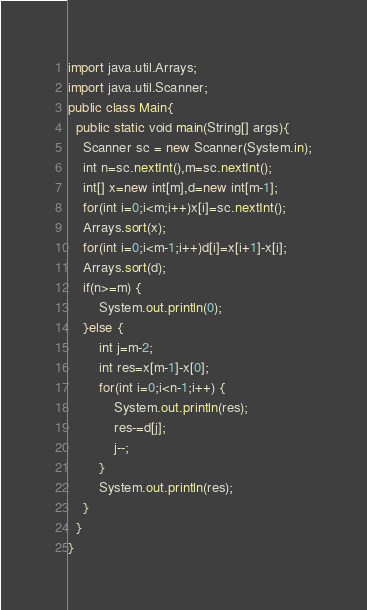<code> <loc_0><loc_0><loc_500><loc_500><_Java_>import java.util.Arrays;
import java.util.Scanner;
public class Main{
  public static void main(String[] args){
    Scanner sc = new Scanner(System.in);
    int n=sc.nextInt(),m=sc.nextInt();
    int[] x=new int[m],d=new int[m-1];
    for(int i=0;i<m;i++)x[i]=sc.nextInt();
    Arrays.sort(x);
    for(int i=0;i<m-1;i++)d[i]=x[i+1]-x[i];
    Arrays.sort(d);
    if(n>=m) {
    	System.out.println(0);
    }else {
    	int j=m-2;
    	int res=x[m-1]-x[0];
    	for(int i=0;i<n-1;i++) {
    		System.out.println(res);
    		res-=d[j];
    		j--;
    	}
    	System.out.println(res);
    }
  }
}
</code> 